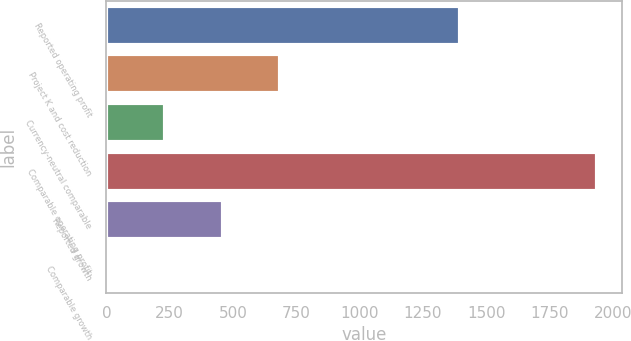Convert chart. <chart><loc_0><loc_0><loc_500><loc_500><bar_chart><fcel>Reported operating profit<fcel>Project K and cost reduction<fcel>Currency-neutral comparable<fcel>Comparable operating profit<fcel>Reported growth<fcel>Comparable growth<nl><fcel>1395<fcel>686.61<fcel>231.07<fcel>1939<fcel>458.84<fcel>3.3<nl></chart> 